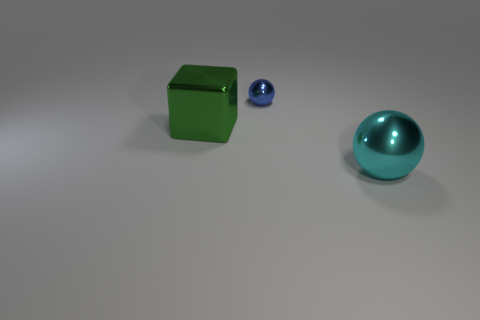There is a big shiny thing behind the sphere that is in front of the large metallic thing that is on the left side of the tiny blue metal object; what is its color?
Offer a terse response. Green. What size is the blue thing that is the same shape as the large cyan metal thing?
Offer a very short reply. Small. Are there the same number of green metal things that are behind the small blue shiny ball and tiny blue balls that are to the left of the large cyan metal object?
Offer a very short reply. No. How many other objects are there of the same material as the blue object?
Your answer should be very brief. 2. Is the number of big green cubes that are in front of the large cyan ball the same as the number of tiny yellow metal cylinders?
Make the answer very short. Yes. Does the cyan sphere have the same size as the object on the left side of the small blue metal object?
Your response must be concise. Yes. There is a big object to the left of the big cyan metal thing; what shape is it?
Give a very brief answer. Cube. Is there anything else that is the same shape as the cyan thing?
Ensure brevity in your answer.  Yes. Are any tiny gray blocks visible?
Provide a short and direct response. No. There is a shiny sphere that is right of the blue shiny ball; is its size the same as the sphere on the left side of the cyan ball?
Ensure brevity in your answer.  No. 